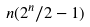Convert formula to latex. <formula><loc_0><loc_0><loc_500><loc_500>n ( 2 ^ { n } / 2 - 1 )</formula> 